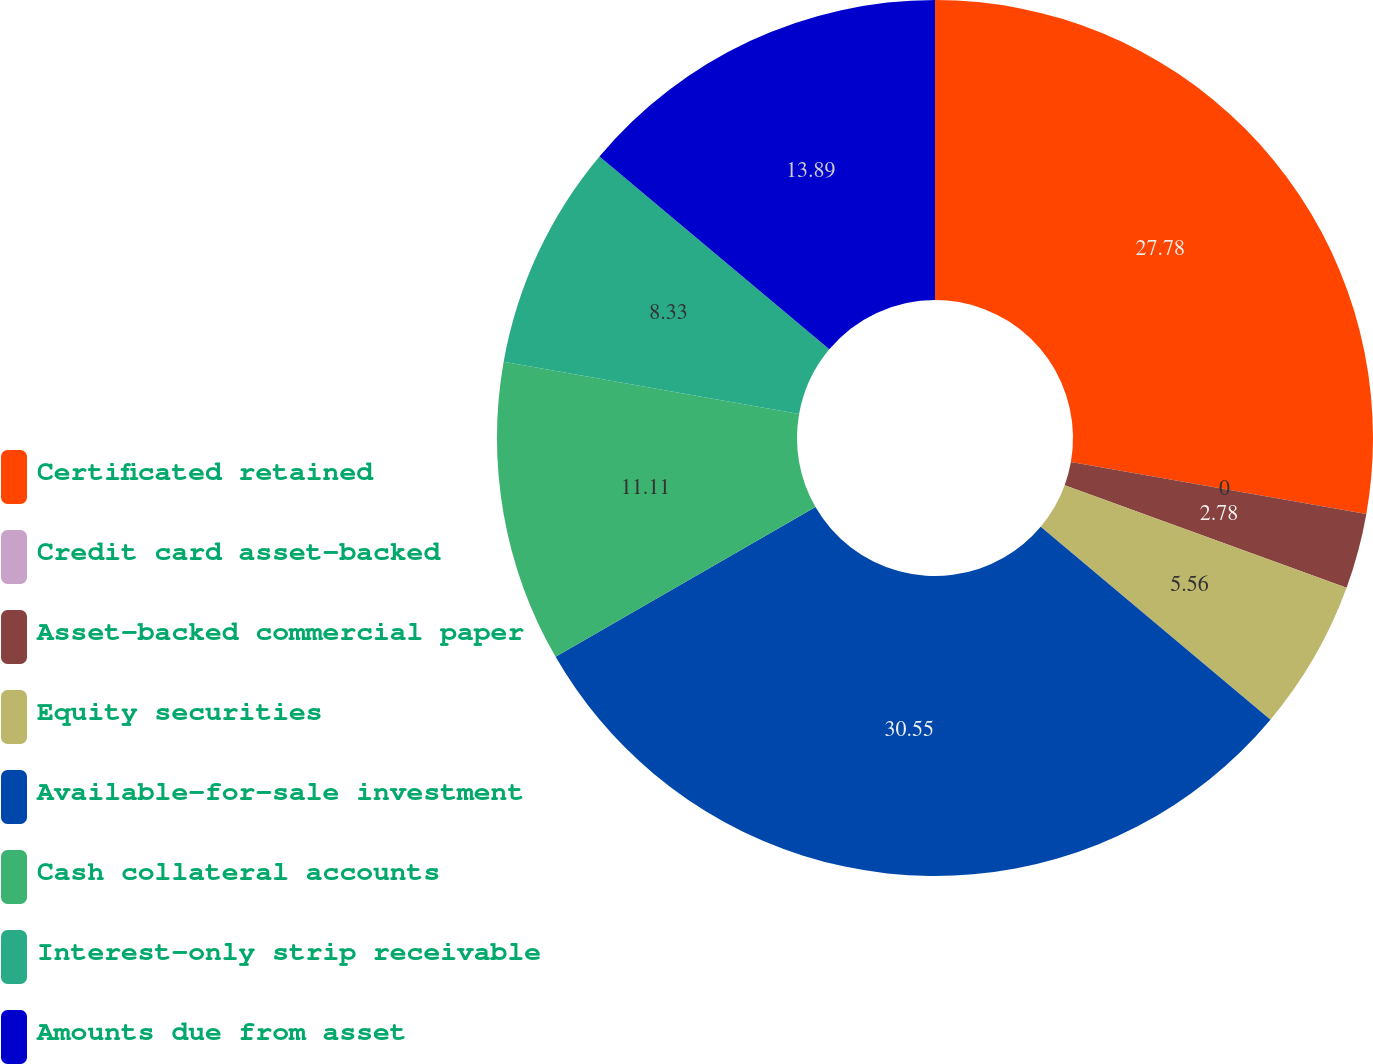Convert chart to OTSL. <chart><loc_0><loc_0><loc_500><loc_500><pie_chart><fcel>Certificated retained<fcel>Credit card asset-backed<fcel>Asset-backed commercial paper<fcel>Equity securities<fcel>Available-for-sale investment<fcel>Cash collateral accounts<fcel>Interest-only strip receivable<fcel>Amounts due from asset<nl><fcel>27.78%<fcel>0.0%<fcel>2.78%<fcel>5.56%<fcel>30.56%<fcel>11.11%<fcel>8.33%<fcel>13.89%<nl></chart> 